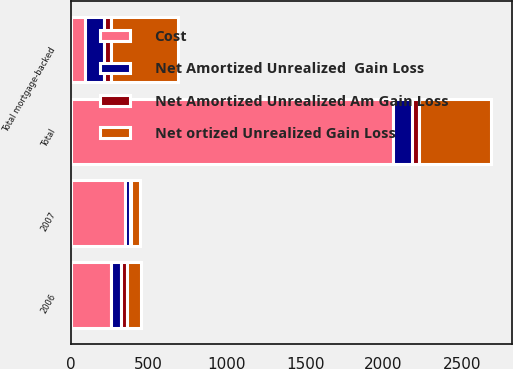<chart> <loc_0><loc_0><loc_500><loc_500><stacked_bar_chart><ecel><fcel>2006<fcel>2007<fcel>Total<fcel>Total mortgage-backed<nl><fcel>Cost<fcel>260<fcel>347<fcel>2061<fcel>90<nl><fcel>Net ortized Unrealized Gain Loss<fcel>90<fcel>54<fcel>454<fcel>428<nl><fcel>Net Amortized Unrealized  Gain Loss<fcel>63<fcel>32<fcel>124<fcel>124<nl><fcel>Net Amortized Unrealized Am Gain Loss<fcel>35<fcel>10<fcel>45<fcel>45<nl></chart> 